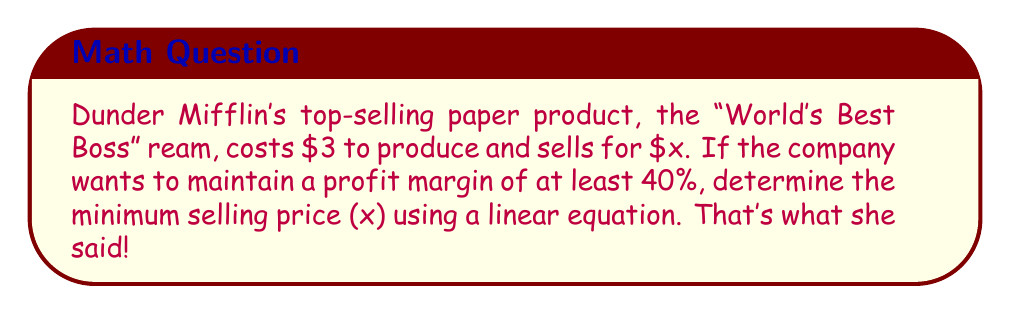Could you help me with this problem? Let's break this down step-by-step:

1) First, let's define our variables:
   $x$ = selling price
   $3$ = production cost

2) The profit is the difference between the selling price and the production cost:
   Profit = $x - 3$

3) The profit margin is calculated as:
   Profit Margin = $\frac{\text{Profit}}{\text{Selling Price}} = \frac{x - 3}{x}$

4) We want this to be at least 40%, or 0.40:
   $\frac{x - 3}{x} \geq 0.40$

5) Now, let's solve this inequality:
   $x - 3 \geq 0.40x$
   $x - 0.40x \geq 3$
   $0.60x \geq 3$

6) Divide both sides by 0.60:
   $x \geq \frac{3}{0.60} = 5$

Therefore, to maintain a profit margin of at least 40%, the minimum selling price should be $5.
Answer: $5 